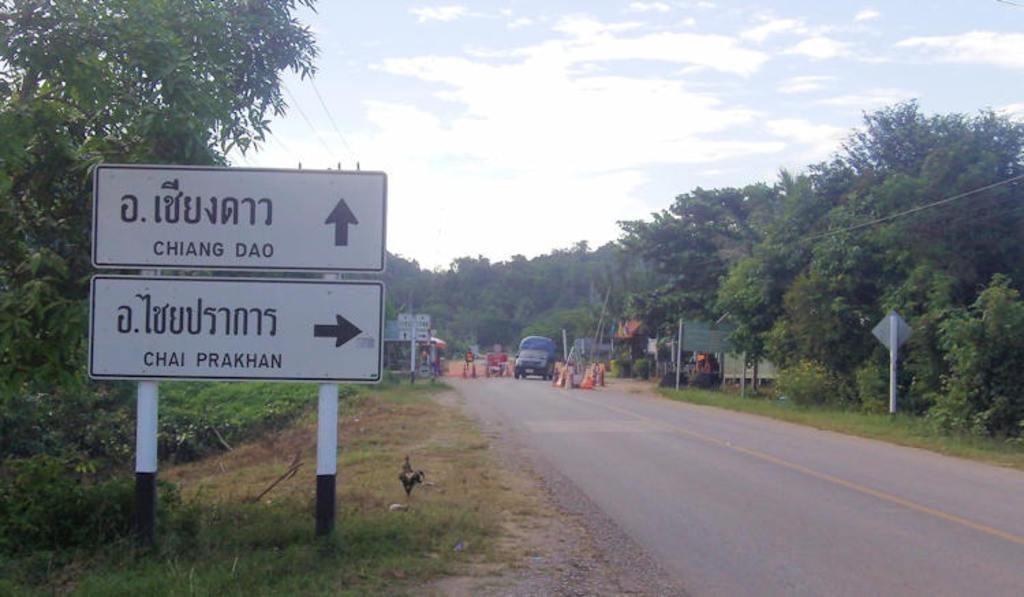Can you describe this image briefly? We can see boards on poles, grass, bird and road. In the background we can see vehicle, traffic cones, boards, poles, plants, trees, wires and sky with clouds. 